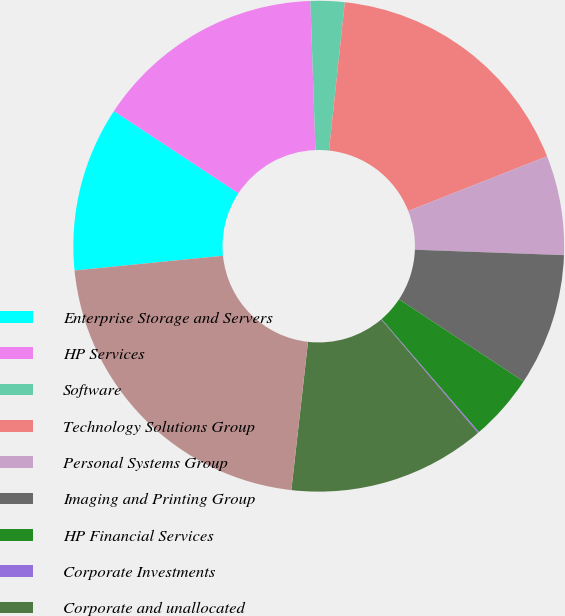Convert chart. <chart><loc_0><loc_0><loc_500><loc_500><pie_chart><fcel>Enterprise Storage and Servers<fcel>HP Services<fcel>Software<fcel>Technology Solutions Group<fcel>Personal Systems Group<fcel>Imaging and Printing Group<fcel>HP Financial Services<fcel>Corporate Investments<fcel>Corporate and unallocated<fcel>Total HP consolidated assets<nl><fcel>10.86%<fcel>15.17%<fcel>2.24%<fcel>17.33%<fcel>6.55%<fcel>8.71%<fcel>4.39%<fcel>0.08%<fcel>13.02%<fcel>21.64%<nl></chart> 